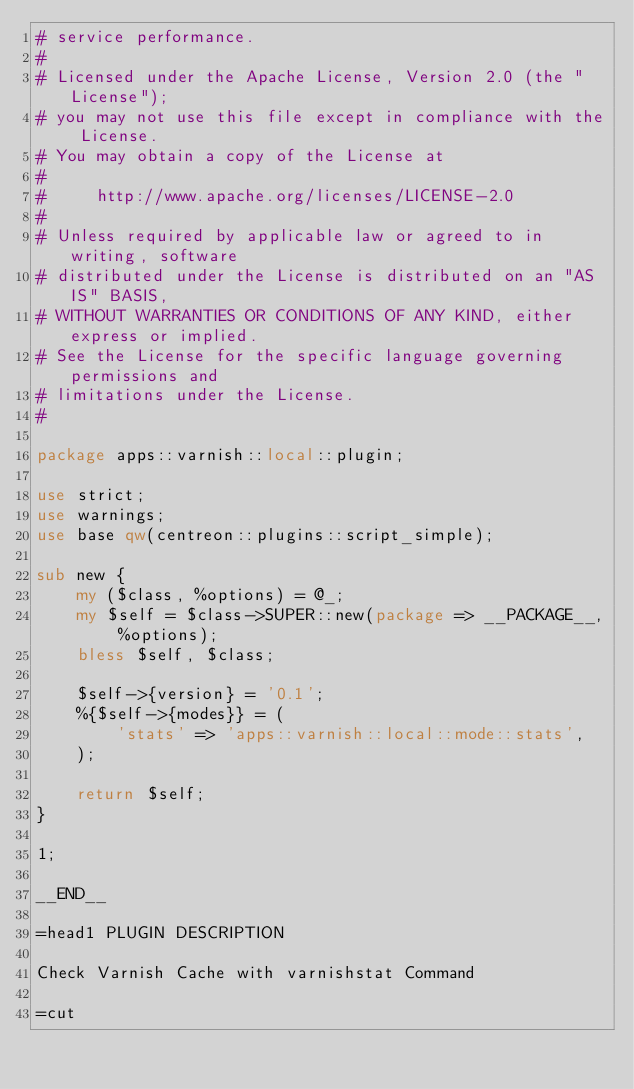<code> <loc_0><loc_0><loc_500><loc_500><_Perl_># service performance.
#
# Licensed under the Apache License, Version 2.0 (the "License");
# you may not use this file except in compliance with the License.
# You may obtain a copy of the License at
#
#     http://www.apache.org/licenses/LICENSE-2.0
#
# Unless required by applicable law or agreed to in writing, software
# distributed under the License is distributed on an "AS IS" BASIS,
# WITHOUT WARRANTIES OR CONDITIONS OF ANY KIND, either express or implied.
# See the License for the specific language governing permissions and
# limitations under the License.
#

package apps::varnish::local::plugin;

use strict;
use warnings;
use base qw(centreon::plugins::script_simple);

sub new {
    my ($class, %options) = @_;
    my $self = $class->SUPER::new(package => __PACKAGE__, %options);
    bless $self, $class;

    $self->{version} = '0.1';
    %{$self->{modes}} = (        
        'stats' => 'apps::varnish::local::mode::stats',
    );

    return $self;
}

1;

__END__

=head1 PLUGIN DESCRIPTION

Check Varnish Cache with varnishstat Command

=cut
</code> 